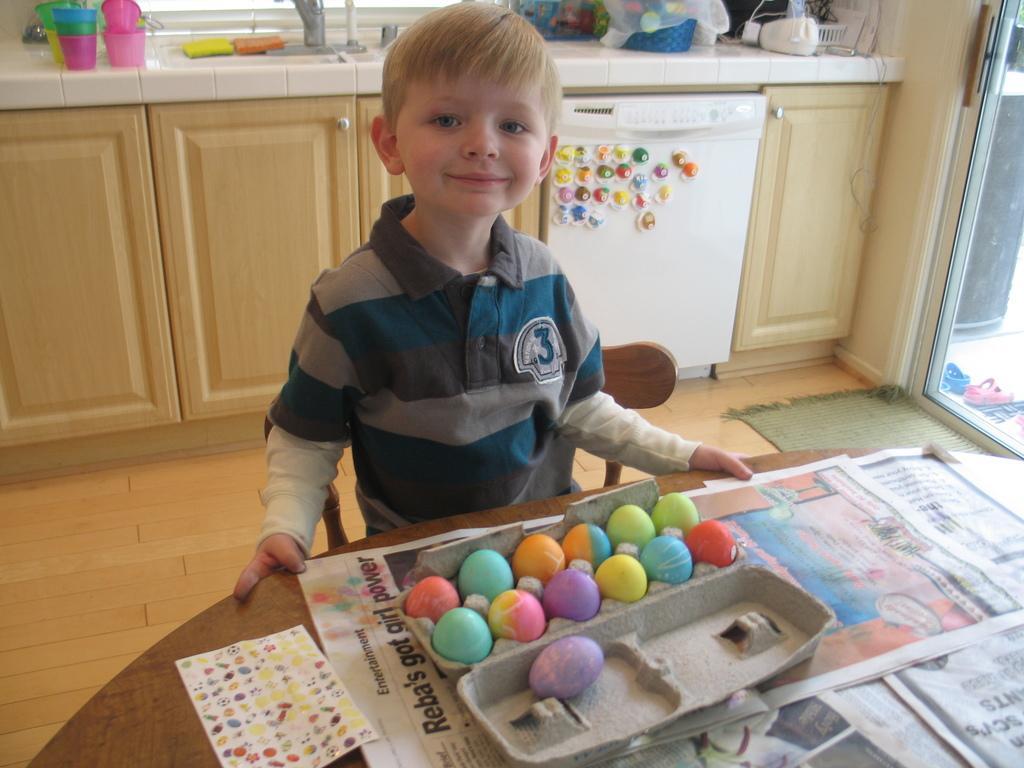Please provide a concise description of this image. As we can see in the image there is a table, box, a boy standing over here, cupboards, sink, glasses and a door. On table there are newspapers. 